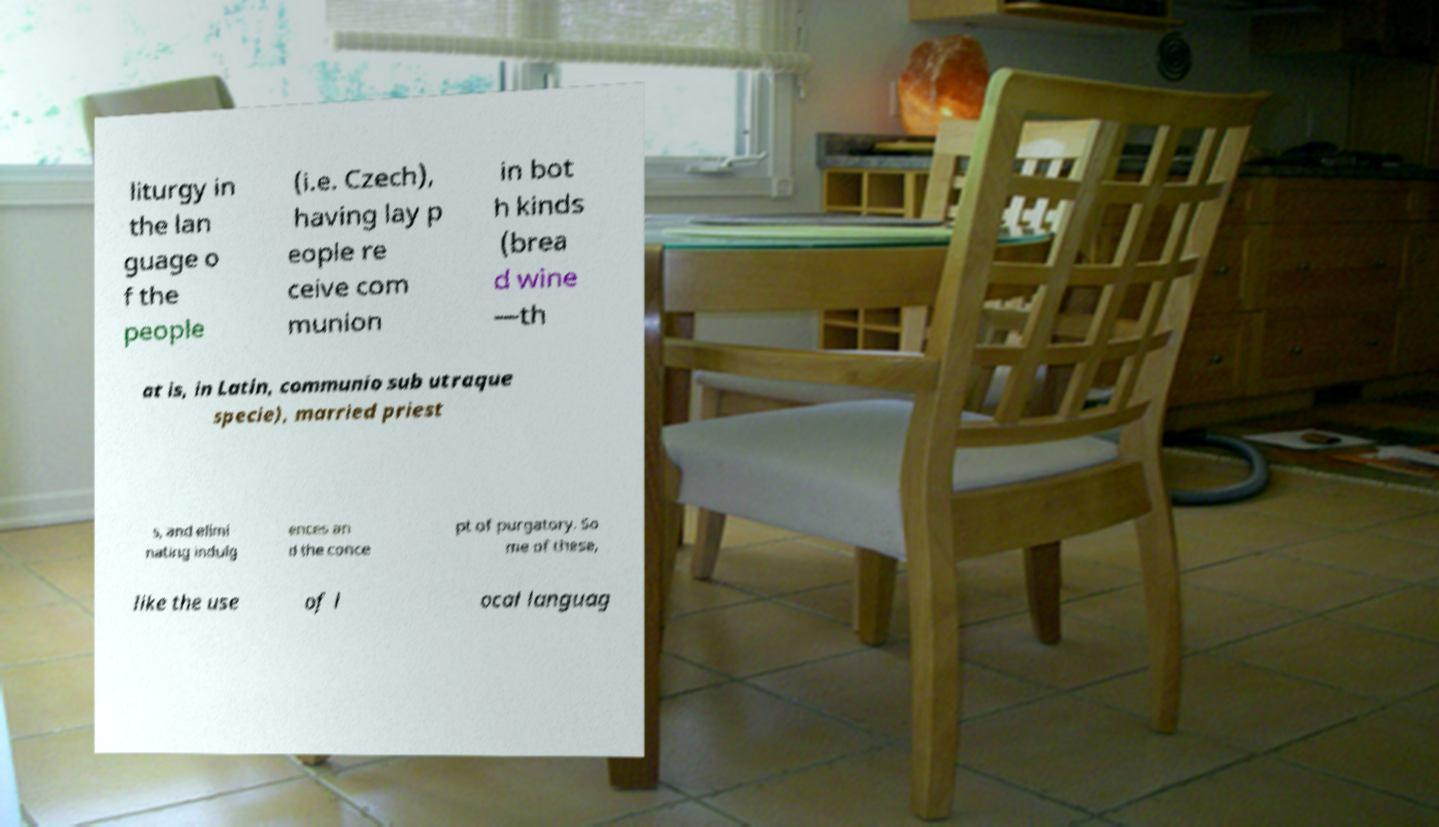Could you assist in decoding the text presented in this image and type it out clearly? liturgy in the lan guage o f the people (i.e. Czech), having lay p eople re ceive com munion in bot h kinds (brea d wine —th at is, in Latin, communio sub utraque specie), married priest s, and elimi nating indulg ences an d the conce pt of purgatory. So me of these, like the use of l ocal languag 